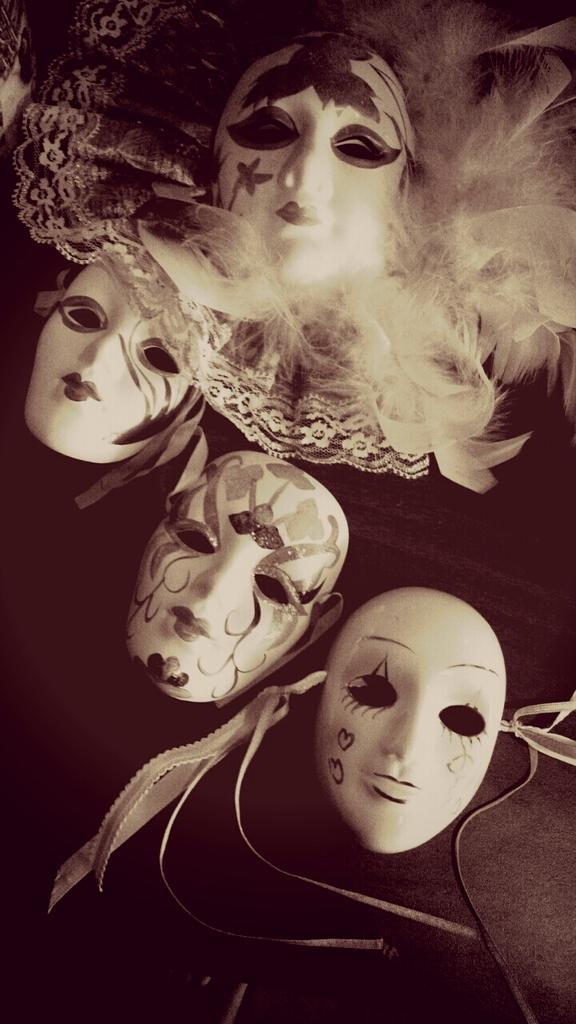What objects are present in the image? There are face masks in the image. Where are the face masks located? The face masks are on a surface. Who is the creator of the face masks in the image? The image does not provide information about the creator of the face masks. 